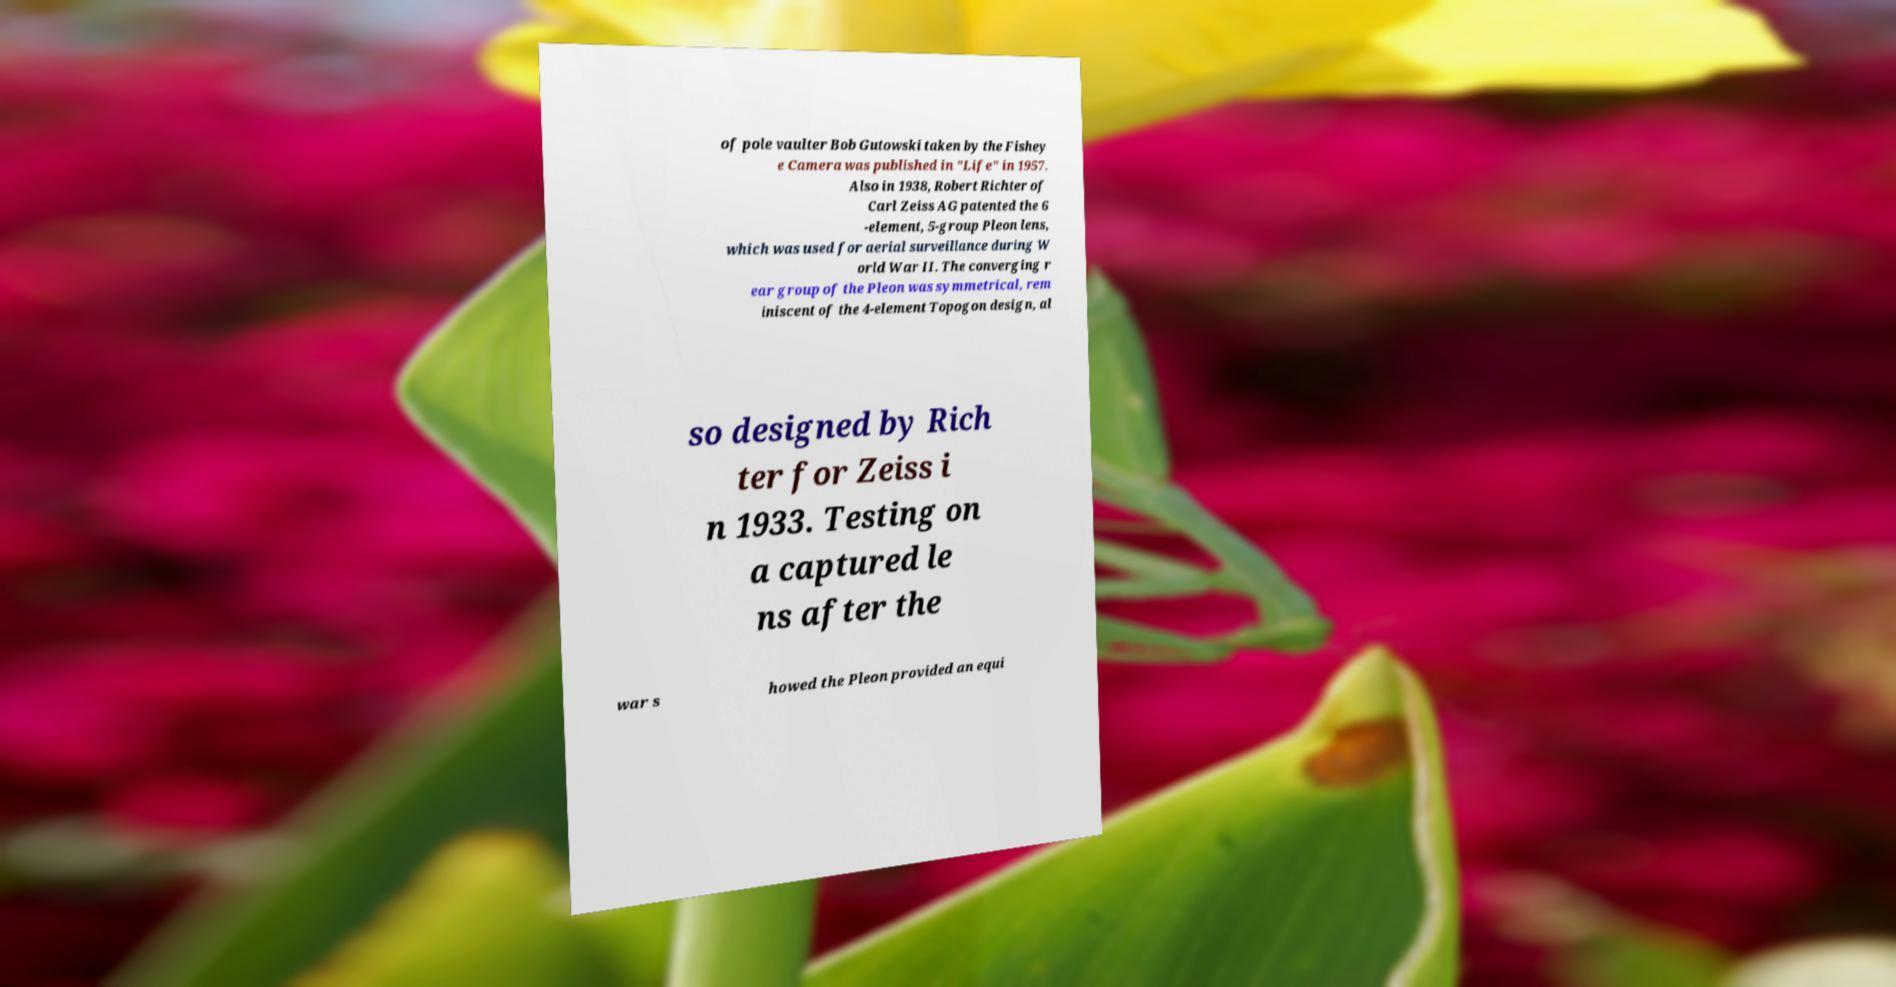For documentation purposes, I need the text within this image transcribed. Could you provide that? of pole vaulter Bob Gutowski taken by the Fishey e Camera was published in "Life" in 1957. Also in 1938, Robert Richter of Carl Zeiss AG patented the 6 -element, 5-group Pleon lens, which was used for aerial surveillance during W orld War II. The converging r ear group of the Pleon was symmetrical, rem iniscent of the 4-element Topogon design, al so designed by Rich ter for Zeiss i n 1933. Testing on a captured le ns after the war s howed the Pleon provided an equi 